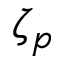Convert formula to latex. <formula><loc_0><loc_0><loc_500><loc_500>\zeta _ { p }</formula> 